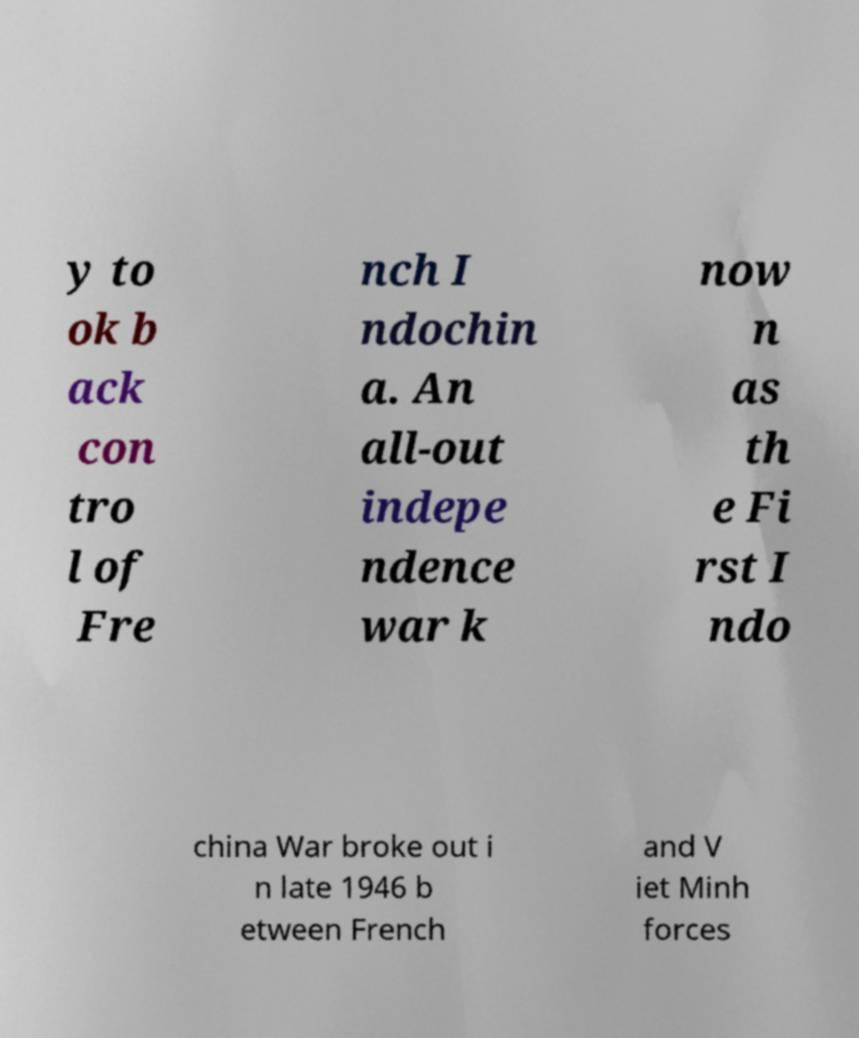There's text embedded in this image that I need extracted. Can you transcribe it verbatim? y to ok b ack con tro l of Fre nch I ndochin a. An all-out indepe ndence war k now n as th e Fi rst I ndo china War broke out i n late 1946 b etween French and V iet Minh forces 